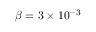Convert formula to latex. <formula><loc_0><loc_0><loc_500><loc_500>\beta = 3 \times 1 0 ^ { - 3 }</formula> 